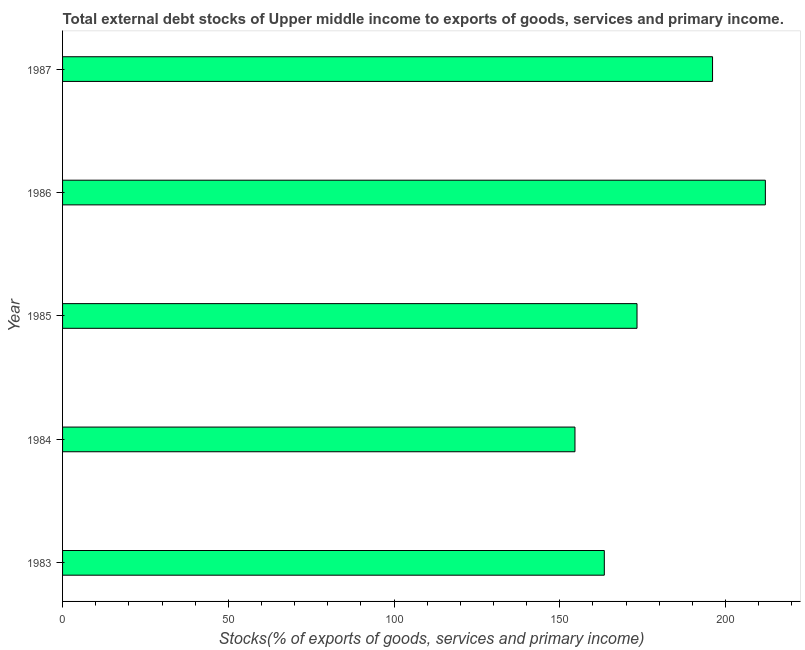Does the graph contain any zero values?
Provide a short and direct response. No. Does the graph contain grids?
Make the answer very short. No. What is the title of the graph?
Keep it short and to the point. Total external debt stocks of Upper middle income to exports of goods, services and primary income. What is the label or title of the X-axis?
Keep it short and to the point. Stocks(% of exports of goods, services and primary income). What is the label or title of the Y-axis?
Make the answer very short. Year. What is the external debt stocks in 1985?
Ensure brevity in your answer.  173.28. Across all years, what is the maximum external debt stocks?
Make the answer very short. 211.99. Across all years, what is the minimum external debt stocks?
Provide a succinct answer. 154.56. In which year was the external debt stocks minimum?
Your answer should be very brief. 1984. What is the sum of the external debt stocks?
Make the answer very short. 899.31. What is the difference between the external debt stocks in 1984 and 1987?
Your answer should be compact. -41.5. What is the average external debt stocks per year?
Your answer should be compact. 179.86. What is the median external debt stocks?
Give a very brief answer. 173.28. What is the ratio of the external debt stocks in 1984 to that in 1987?
Your answer should be compact. 0.79. Is the difference between the external debt stocks in 1986 and 1987 greater than the difference between any two years?
Keep it short and to the point. No. What is the difference between the highest and the second highest external debt stocks?
Offer a terse response. 15.93. Is the sum of the external debt stocks in 1983 and 1987 greater than the maximum external debt stocks across all years?
Give a very brief answer. Yes. What is the difference between the highest and the lowest external debt stocks?
Make the answer very short. 57.43. How many years are there in the graph?
Provide a succinct answer. 5. What is the difference between two consecutive major ticks on the X-axis?
Your answer should be very brief. 50. Are the values on the major ticks of X-axis written in scientific E-notation?
Ensure brevity in your answer.  No. What is the Stocks(% of exports of goods, services and primary income) in 1983?
Give a very brief answer. 163.42. What is the Stocks(% of exports of goods, services and primary income) in 1984?
Your response must be concise. 154.56. What is the Stocks(% of exports of goods, services and primary income) in 1985?
Offer a very short reply. 173.28. What is the Stocks(% of exports of goods, services and primary income) of 1986?
Offer a terse response. 211.99. What is the Stocks(% of exports of goods, services and primary income) of 1987?
Provide a succinct answer. 196.06. What is the difference between the Stocks(% of exports of goods, services and primary income) in 1983 and 1984?
Make the answer very short. 8.85. What is the difference between the Stocks(% of exports of goods, services and primary income) in 1983 and 1985?
Make the answer very short. -9.87. What is the difference between the Stocks(% of exports of goods, services and primary income) in 1983 and 1986?
Your response must be concise. -48.58. What is the difference between the Stocks(% of exports of goods, services and primary income) in 1983 and 1987?
Your response must be concise. -32.65. What is the difference between the Stocks(% of exports of goods, services and primary income) in 1984 and 1985?
Keep it short and to the point. -18.72. What is the difference between the Stocks(% of exports of goods, services and primary income) in 1984 and 1986?
Provide a short and direct response. -57.43. What is the difference between the Stocks(% of exports of goods, services and primary income) in 1984 and 1987?
Offer a terse response. -41.5. What is the difference between the Stocks(% of exports of goods, services and primary income) in 1985 and 1986?
Give a very brief answer. -38.71. What is the difference between the Stocks(% of exports of goods, services and primary income) in 1985 and 1987?
Keep it short and to the point. -22.78. What is the difference between the Stocks(% of exports of goods, services and primary income) in 1986 and 1987?
Offer a very short reply. 15.93. What is the ratio of the Stocks(% of exports of goods, services and primary income) in 1983 to that in 1984?
Provide a short and direct response. 1.06. What is the ratio of the Stocks(% of exports of goods, services and primary income) in 1983 to that in 1985?
Ensure brevity in your answer.  0.94. What is the ratio of the Stocks(% of exports of goods, services and primary income) in 1983 to that in 1986?
Ensure brevity in your answer.  0.77. What is the ratio of the Stocks(% of exports of goods, services and primary income) in 1983 to that in 1987?
Your answer should be very brief. 0.83. What is the ratio of the Stocks(% of exports of goods, services and primary income) in 1984 to that in 1985?
Provide a succinct answer. 0.89. What is the ratio of the Stocks(% of exports of goods, services and primary income) in 1984 to that in 1986?
Offer a terse response. 0.73. What is the ratio of the Stocks(% of exports of goods, services and primary income) in 1984 to that in 1987?
Your answer should be very brief. 0.79. What is the ratio of the Stocks(% of exports of goods, services and primary income) in 1985 to that in 1986?
Offer a terse response. 0.82. What is the ratio of the Stocks(% of exports of goods, services and primary income) in 1985 to that in 1987?
Make the answer very short. 0.88. What is the ratio of the Stocks(% of exports of goods, services and primary income) in 1986 to that in 1987?
Offer a very short reply. 1.08. 